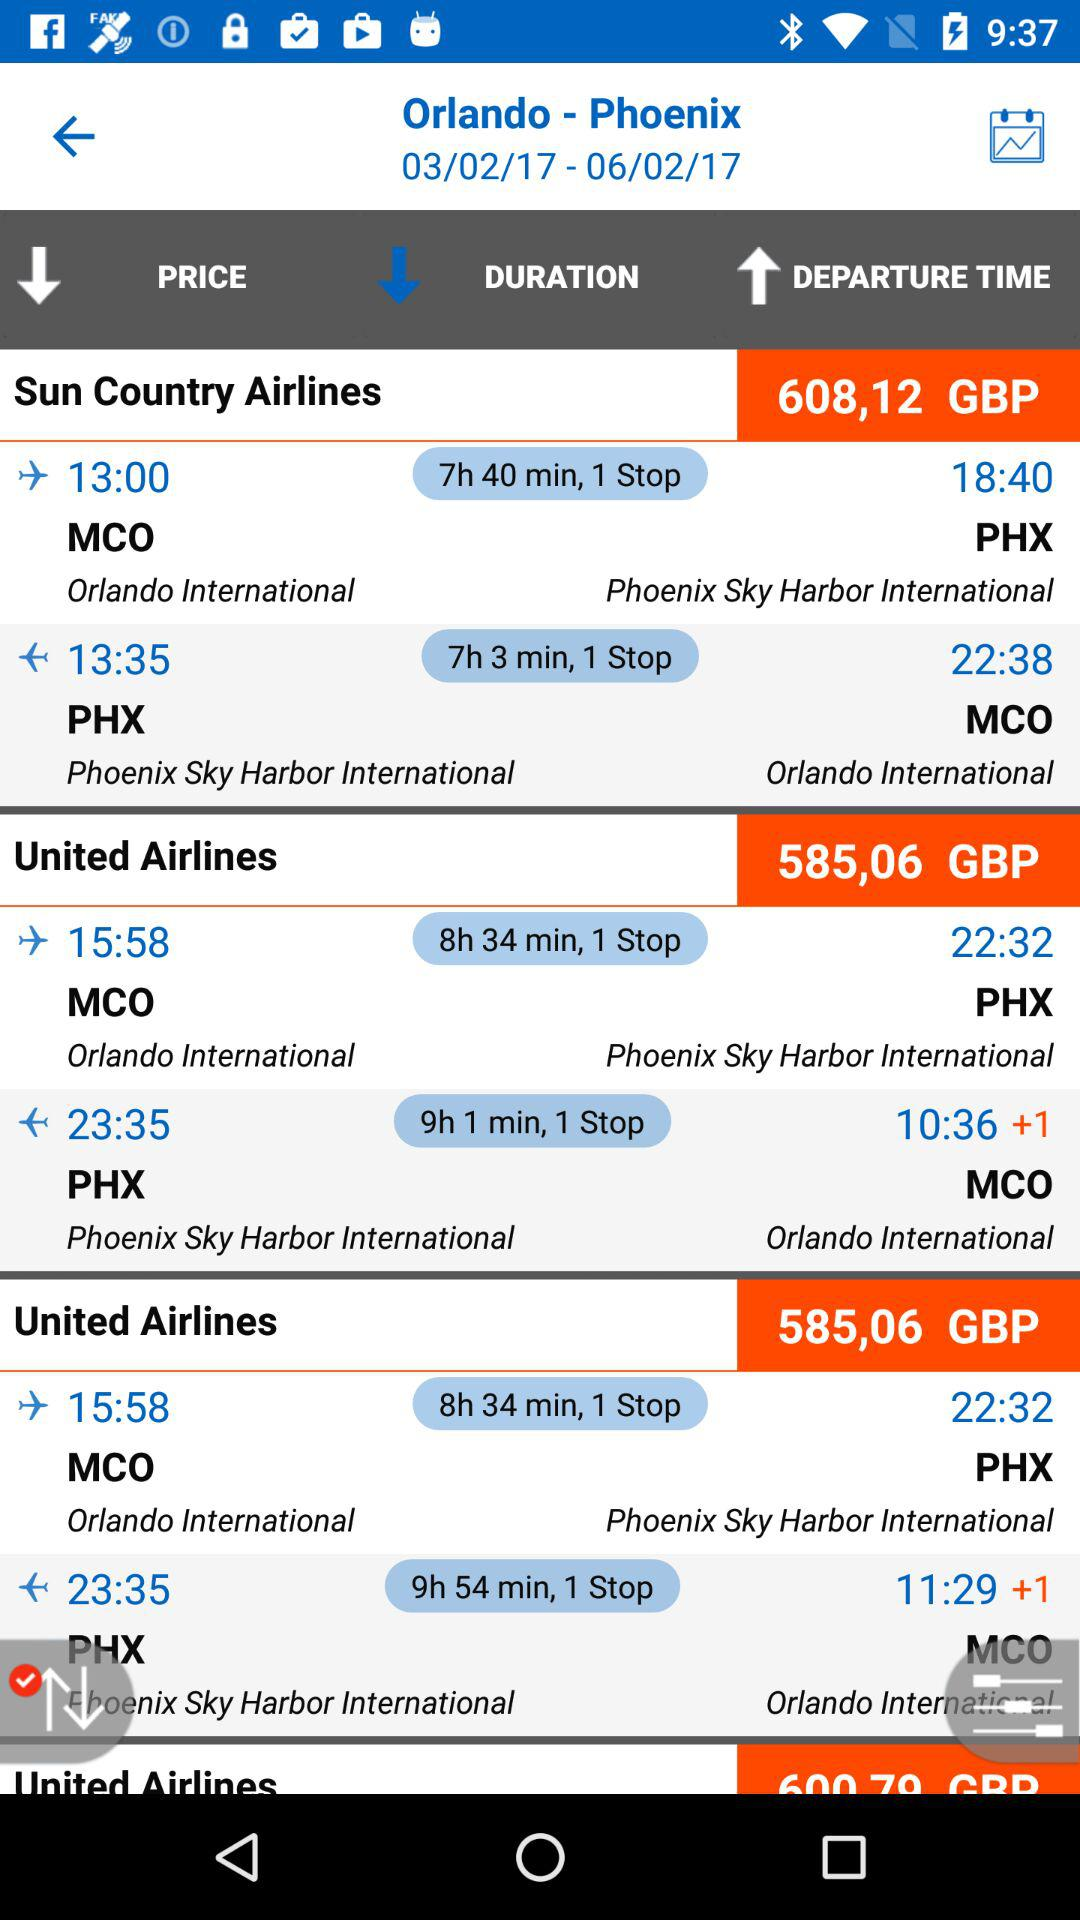How much time will it take to travel from PHX to MCO on Sun County Airlines? It will take 7 hours 3 minutes to travel from PHX to MCO on Sun County Airlines. 